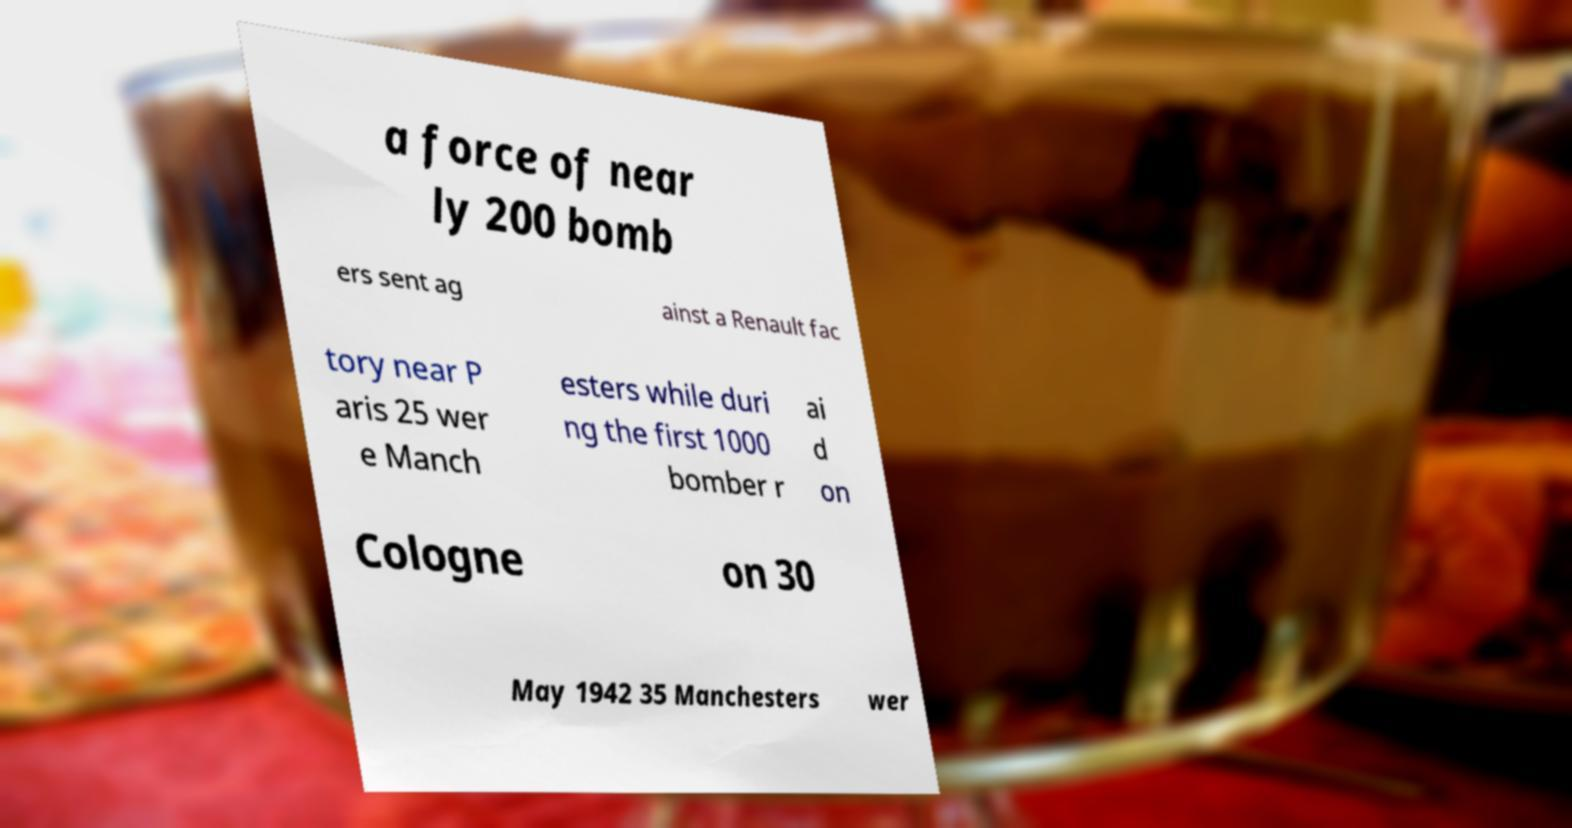Can you read and provide the text displayed in the image?This photo seems to have some interesting text. Can you extract and type it out for me? a force of near ly 200 bomb ers sent ag ainst a Renault fac tory near P aris 25 wer e Manch esters while duri ng the first 1000 bomber r ai d on Cologne on 30 May 1942 35 Manchesters wer 